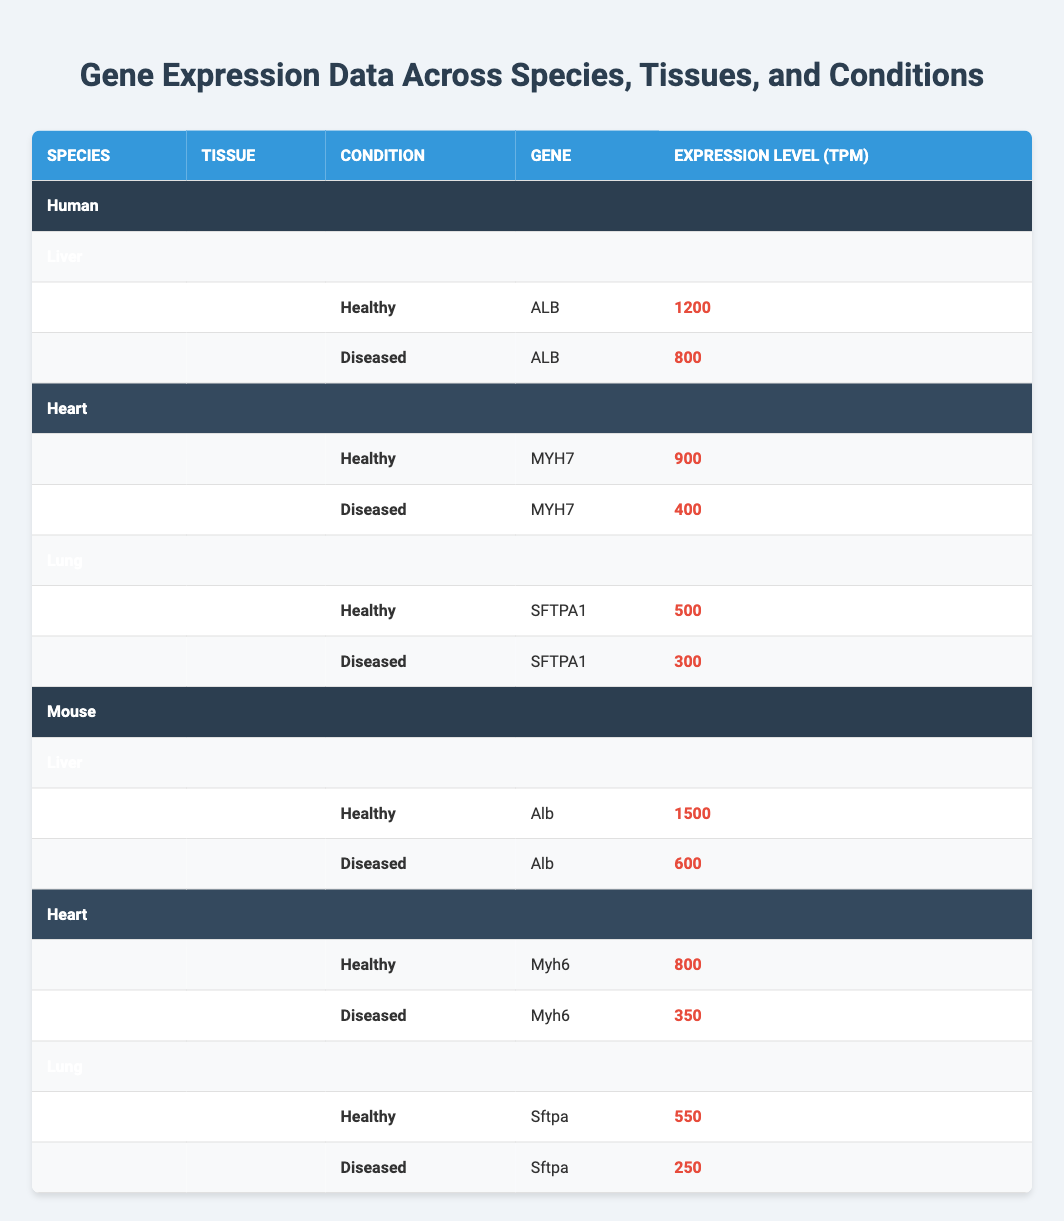What is the expression level of the ALB gene in healthy Human liver tissue? The table shows the data for Human liver tissue under the healthy condition. The entry for the ALB gene indicates an expression level of 1200 TPM.
Answer: 1200 What is the expression level of the MYH7 gene in diseased Human heart tissue? According to the table, for the diseased condition in Human heart tissue, the MYH7 gene has an expression level of 400 TPM.
Answer: 400 Which species shows a higher expression level of Alb in healthy liver tissue, Human or Mouse? The expression level of Alb in healthy Mouse liver tissue is 1500 TPM, while in Human liver tissue, the ALB gene shows a value of 1200 TPM. Therefore, Mouse has a higher expression level.
Answer: Mouse What is the total expression level of the SFTPA1 gene in healthy and diseased Human lung tissue combined? For the SFTPA1 gene in healthy Human lung tissue, the expression level is 500 TPM, and in diseased condition, it is 300 TPM. Adding both gives 500 + 300 = 800 TPM.
Answer: 800 Is the expression level of Myh6 in healthy Mouse heart tissue greater than 700 TPM? The data for healthy Mouse heart tissue shows the expression level of Myh6 is 800 TPM, which is indeed greater than 700 TPM.
Answer: Yes What is the difference in expression levels of the ALB gene between healthy and diseased Human liver tissue? The expression level of ALB in healthy Human liver tissue is 1200 TPM, while in diseased liver tissue it is 800 TPM. The difference is 1200 - 800 = 400 TPM.
Answer: 400 Among all conditions, which gene has the highest expression level, and what is that level? Reviewing all entries, the highest expression level is for Alb in healthy Mouse liver tissue at 1500 TPM.
Answer: Alb, 1500 What is the average expression level of the Sftpa gene in Mouse lung tissue across both conditions? The expression levels for Sftpa in Mouse lung tissue are 550 TPM (healthy) and 250 TPM (diseased). The sum is 550 + 250 = 800, and dividing that by 2 gives an average of 800/2 = 400 TPM.
Answer: 400 Is there any tissue in which the gene expression level is equal in healthy and diseased conditions? Reviewing the data, all tissue and condition combinations show a difference in expression levels. Therefore, there are no cases where the gene expression level is equal in both conditions.
Answer: No 